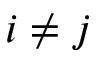<formula> <loc_0><loc_0><loc_500><loc_500>i \neq j</formula> 